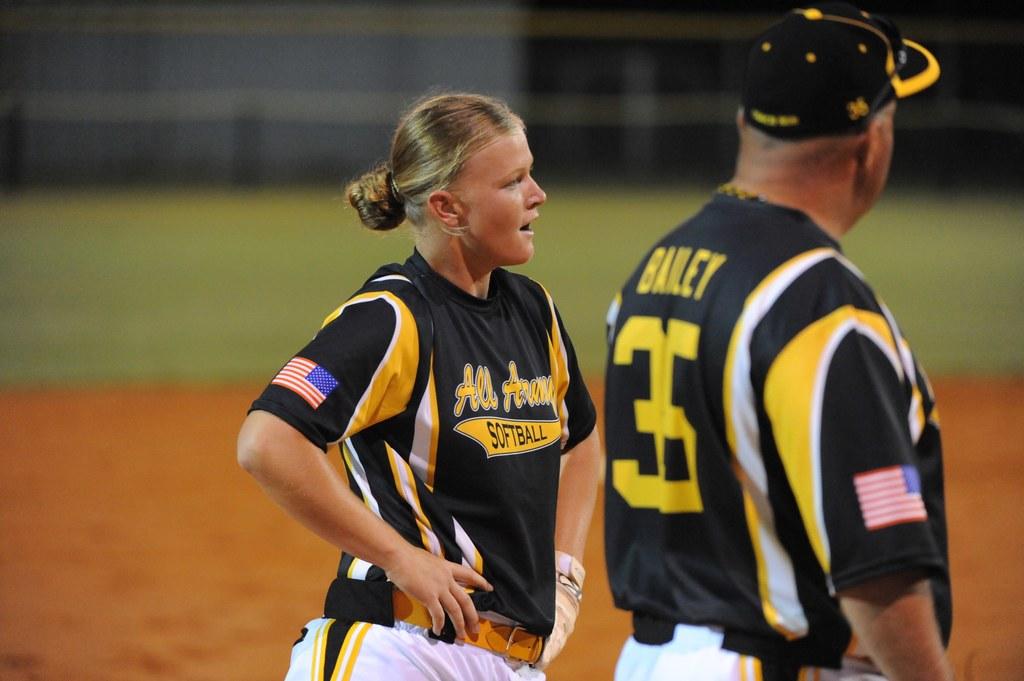What sport are they playing?
Make the answer very short. Softball. What jersey number is the man wearing?
Your answer should be very brief. 35. 